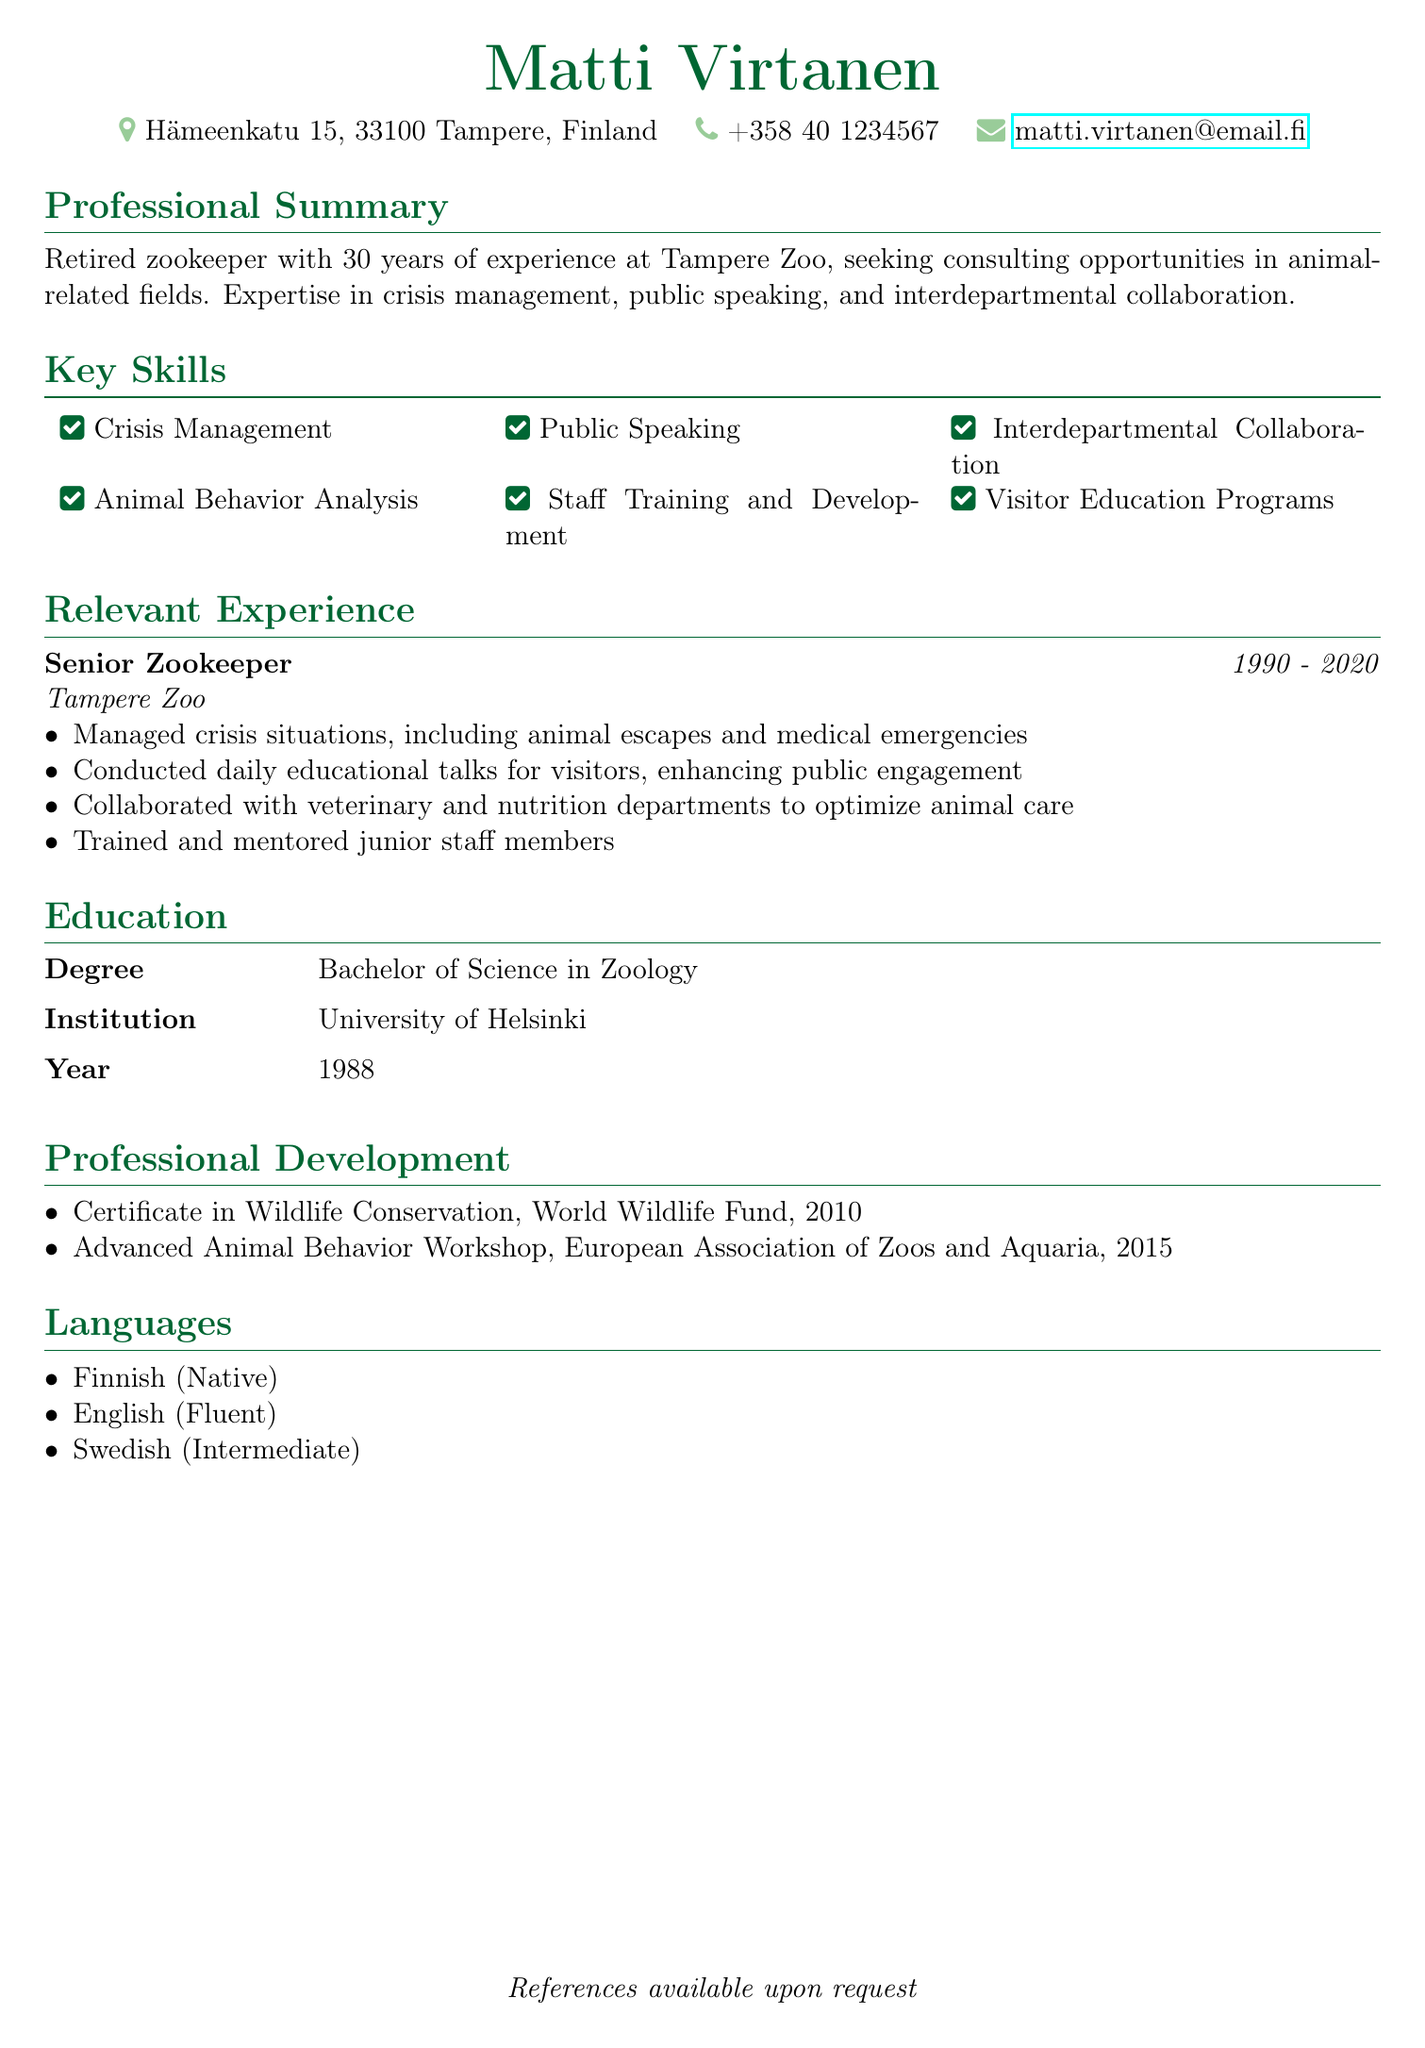What is the name of the individual? The document lists the name of the individual as the heading, which is "Matti Virtanen."
Answer: Matti Virtanen What is the duration of Matti's employment at Tampere Zoo? The relevant experience section specifies that he worked as a Senior Zookeeper from 1990 to 2020.
Answer: 1990 - 2020 What degree did Matti earn? The education section states that he earned a Bachelor of Science in Zoology.
Answer: Bachelor of Science in Zoology Which languages does Matti speak? The languages section lists three languages: Finnish, English, and Swedish.
Answer: Finnish, English, Swedish What is one of Matti's key skills? The key skills section highlights several abilities; one example is crisis management.
Answer: Crisis Management How many years of zookeeping experience does Matti have? The professional summary indicates he has 30 years of experience in zookeeping.
Answer: 30 years What certificate did Matti earn in 2010? The professional development section shows he earned a Certificate in Wildlife Conservation in 2010.
Answer: Certificate in Wildlife Conservation What position did Matti hold at Tampere Zoo? The relevant experience section lists his position as Senior Zookeeper.
Answer: Senior Zookeeper What type of consulting opportunities is Matti seeking? The professional summary specifies that he is seeking consulting opportunities in animal-related fields.
Answer: Animal-related fields 